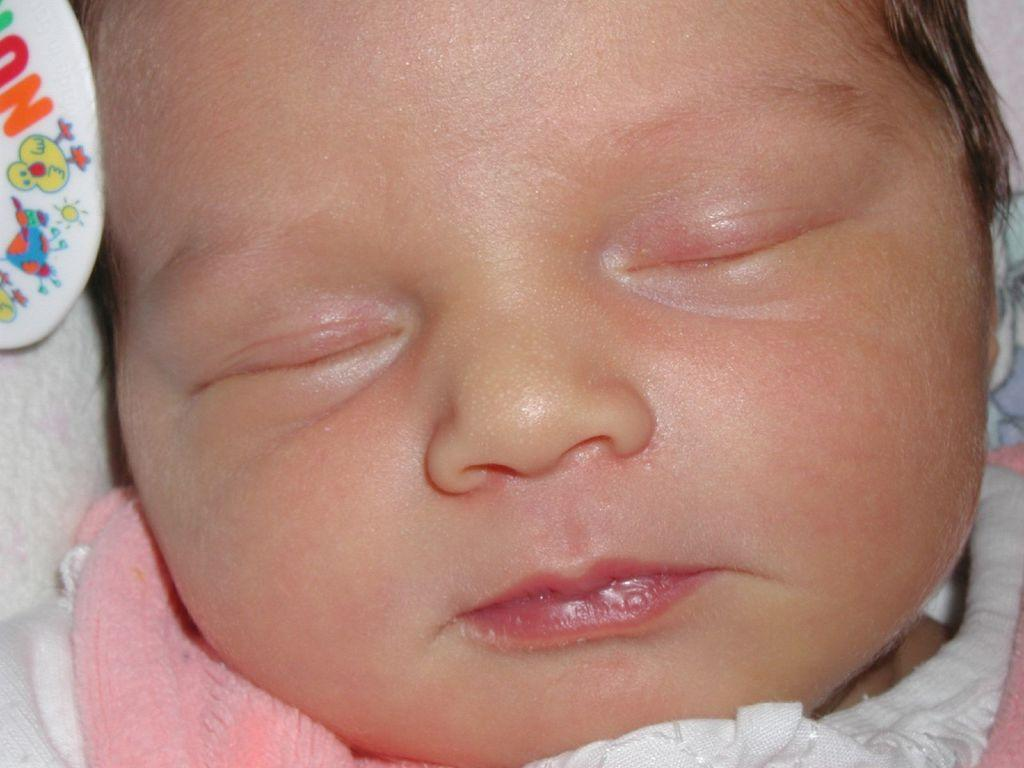What is the main subject of the image? The main subject of the image is a baby. What is the baby doing in the image? The baby is sleeping. What type of sock is the baby wearing in the image? There is no sock visible in the image, as the baby is not wearing any clothing. Is the baby using a screw to build something in the image? There is no screw or any building activity present in the image. 